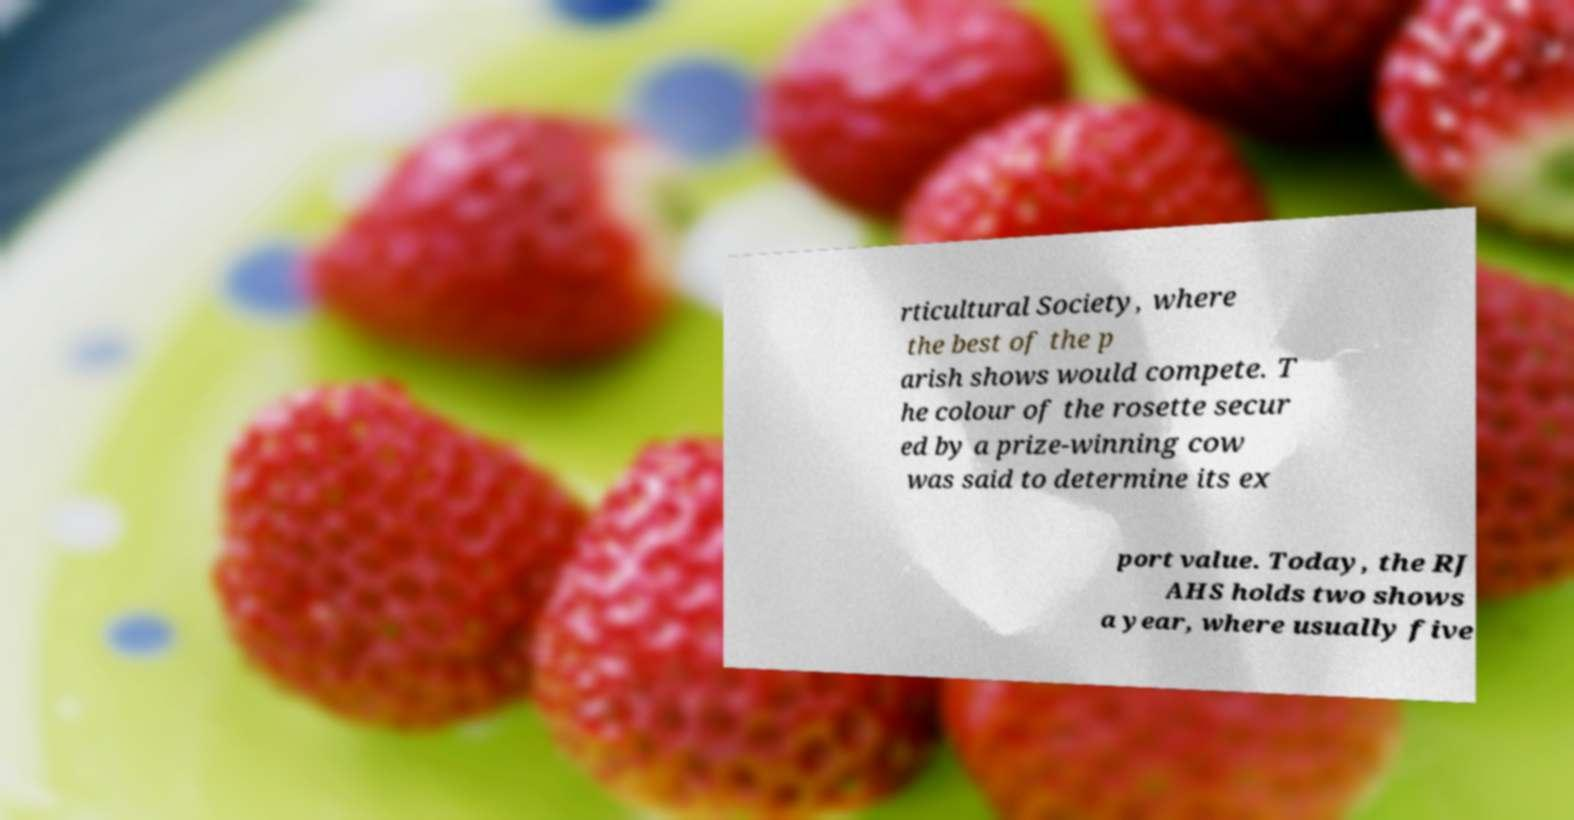Please read and relay the text visible in this image. What does it say? rticultural Society, where the best of the p arish shows would compete. T he colour of the rosette secur ed by a prize-winning cow was said to determine its ex port value. Today, the RJ AHS holds two shows a year, where usually five 